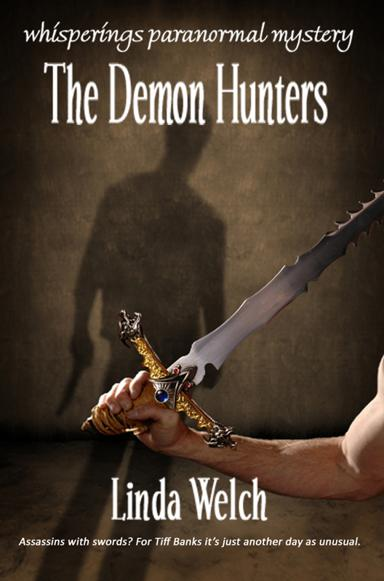What is the title of the book mentioned in the image? The title of the book depicted in the image is "The Demon Hunters," authored by Linda Welch. The cover features a dramatic portrayal of a hand wielding an ornate sword, hinting at a thrilling narrative infused with fantasy and danger. 